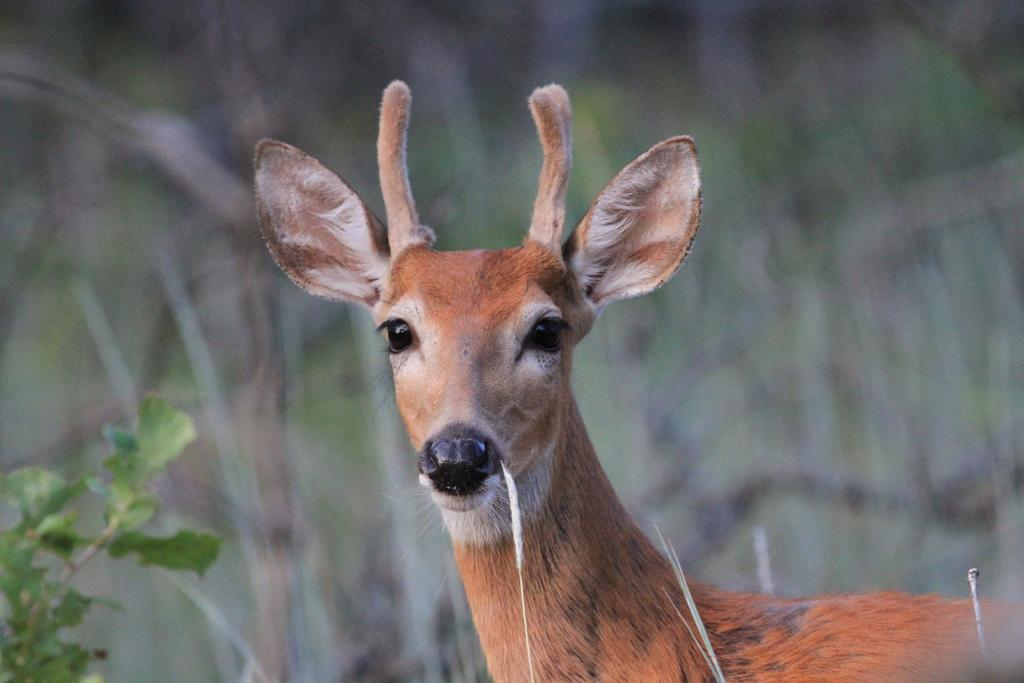What type of living organism can be seen in the image? There is an animal in the image. What type of plant material is present in the image? Leaves and a stem are visible in the image. How would you describe the background of the image? The background of the image is blurred. What type of addition problem can be solved using the leaves in the image? There is no addition problem present in the image, as it features an animal and plant material. 